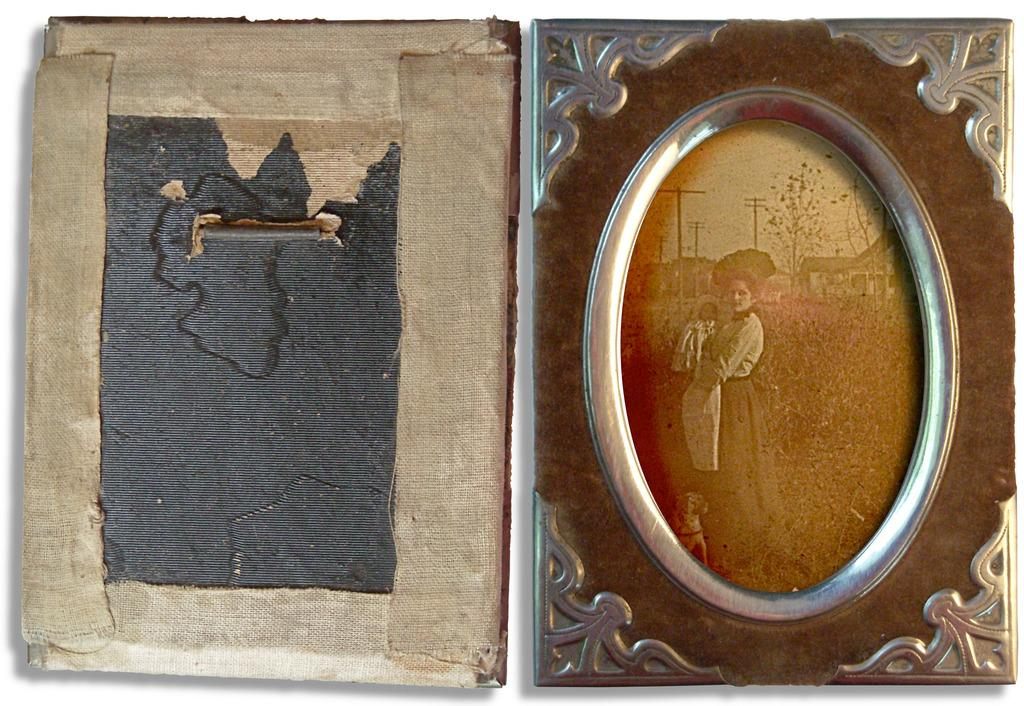What is the main subject of the image? The main subject of the image is a vintage photograph in a frame. Where is the frame located in the image? The frame is on the right side of the image. What else can be seen beside the vintage photograph? There is a cardboard beside the vintage photograph. What type of coil is used for the treatment of the vintage photograph in the image? There is no mention of a coil or treatment in the image; it simply shows a vintage photograph in a frame with a cardboard beside it. 